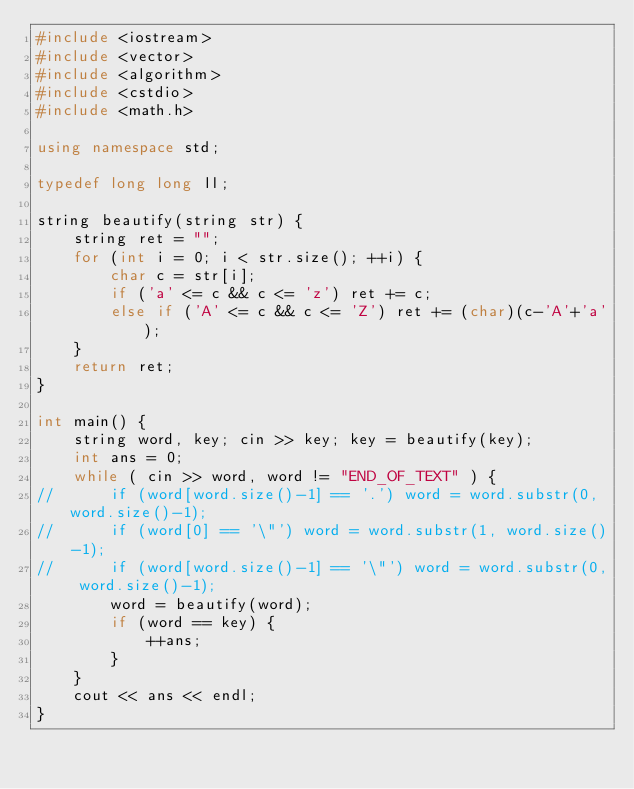<code> <loc_0><loc_0><loc_500><loc_500><_C++_>#include <iostream>
#include <vector>
#include <algorithm>
#include <cstdio>
#include <math.h>

using namespace std;

typedef long long ll;

string beautify(string str) {
	string ret = "";
	for (int i = 0; i < str.size(); ++i) {
		char c = str[i];
		if ('a' <= c && c <= 'z') ret += c;
		else if ('A' <= c && c <= 'Z') ret += (char)(c-'A'+'a');
	}
	return ret;
}

int main() {
	string word, key; cin >> key; key = beautify(key);
	int ans = 0;
	while ( cin >> word, word != "END_OF_TEXT" ) {
//		if (word[word.size()-1] == '.') word = word.substr(0, word.size()-1);
//		if (word[0] == '\"') word = word.substr(1, word.size()-1);
//		if (word[word.size()-1] == '\"') word = word.substr(0, word.size()-1);
		word = beautify(word);
		if (word == key) {
			++ans;
		}
	}
	cout << ans << endl;
}</code> 